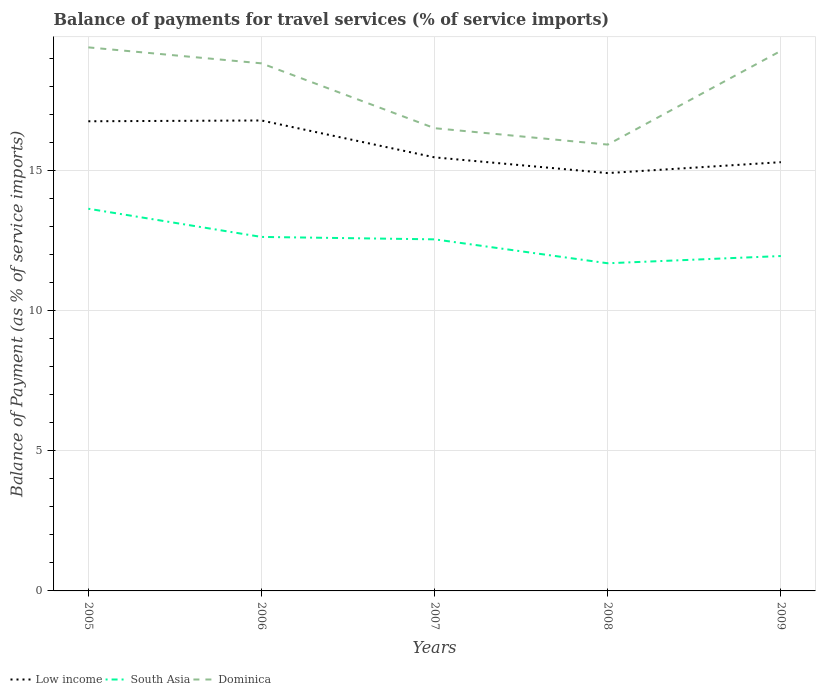Across all years, what is the maximum balance of payments for travel services in South Asia?
Provide a short and direct response. 11.69. What is the total balance of payments for travel services in Low income in the graph?
Your response must be concise. 1.29. What is the difference between the highest and the second highest balance of payments for travel services in Dominica?
Keep it short and to the point. 3.47. What is the difference between the highest and the lowest balance of payments for travel services in South Asia?
Make the answer very short. 3. Is the balance of payments for travel services in South Asia strictly greater than the balance of payments for travel services in Dominica over the years?
Your answer should be very brief. Yes. How many years are there in the graph?
Give a very brief answer. 5. Does the graph contain grids?
Provide a succinct answer. Yes. How are the legend labels stacked?
Offer a terse response. Horizontal. What is the title of the graph?
Make the answer very short. Balance of payments for travel services (% of service imports). Does "Turks and Caicos Islands" appear as one of the legend labels in the graph?
Provide a succinct answer. No. What is the label or title of the Y-axis?
Provide a short and direct response. Balance of Payment (as % of service imports). What is the Balance of Payment (as % of service imports) in Low income in 2005?
Offer a terse response. 16.76. What is the Balance of Payment (as % of service imports) of South Asia in 2005?
Provide a short and direct response. 13.64. What is the Balance of Payment (as % of service imports) in Dominica in 2005?
Provide a short and direct response. 19.4. What is the Balance of Payment (as % of service imports) in Low income in 2006?
Provide a succinct answer. 16.79. What is the Balance of Payment (as % of service imports) of South Asia in 2006?
Your answer should be very brief. 12.63. What is the Balance of Payment (as % of service imports) of Dominica in 2006?
Your response must be concise. 18.83. What is the Balance of Payment (as % of service imports) of Low income in 2007?
Your answer should be compact. 15.47. What is the Balance of Payment (as % of service imports) of South Asia in 2007?
Ensure brevity in your answer.  12.55. What is the Balance of Payment (as % of service imports) in Dominica in 2007?
Your answer should be compact. 16.51. What is the Balance of Payment (as % of service imports) in Low income in 2008?
Keep it short and to the point. 14.91. What is the Balance of Payment (as % of service imports) in South Asia in 2008?
Keep it short and to the point. 11.69. What is the Balance of Payment (as % of service imports) of Dominica in 2008?
Offer a terse response. 15.93. What is the Balance of Payment (as % of service imports) of Low income in 2009?
Offer a terse response. 15.3. What is the Balance of Payment (as % of service imports) of South Asia in 2009?
Make the answer very short. 11.95. What is the Balance of Payment (as % of service imports) of Dominica in 2009?
Ensure brevity in your answer.  19.27. Across all years, what is the maximum Balance of Payment (as % of service imports) in Low income?
Keep it short and to the point. 16.79. Across all years, what is the maximum Balance of Payment (as % of service imports) in South Asia?
Give a very brief answer. 13.64. Across all years, what is the maximum Balance of Payment (as % of service imports) in Dominica?
Make the answer very short. 19.4. Across all years, what is the minimum Balance of Payment (as % of service imports) of Low income?
Give a very brief answer. 14.91. Across all years, what is the minimum Balance of Payment (as % of service imports) of South Asia?
Provide a succinct answer. 11.69. Across all years, what is the minimum Balance of Payment (as % of service imports) of Dominica?
Offer a terse response. 15.93. What is the total Balance of Payment (as % of service imports) in Low income in the graph?
Your answer should be very brief. 79.24. What is the total Balance of Payment (as % of service imports) in South Asia in the graph?
Your response must be concise. 62.46. What is the total Balance of Payment (as % of service imports) of Dominica in the graph?
Your answer should be compact. 89.94. What is the difference between the Balance of Payment (as % of service imports) of Low income in 2005 and that in 2006?
Provide a short and direct response. -0.03. What is the difference between the Balance of Payment (as % of service imports) in South Asia in 2005 and that in 2006?
Make the answer very short. 1.01. What is the difference between the Balance of Payment (as % of service imports) of Dominica in 2005 and that in 2006?
Give a very brief answer. 0.57. What is the difference between the Balance of Payment (as % of service imports) of Low income in 2005 and that in 2007?
Ensure brevity in your answer.  1.29. What is the difference between the Balance of Payment (as % of service imports) of South Asia in 2005 and that in 2007?
Make the answer very short. 1.09. What is the difference between the Balance of Payment (as % of service imports) of Dominica in 2005 and that in 2007?
Offer a terse response. 2.88. What is the difference between the Balance of Payment (as % of service imports) of Low income in 2005 and that in 2008?
Give a very brief answer. 1.85. What is the difference between the Balance of Payment (as % of service imports) in South Asia in 2005 and that in 2008?
Your answer should be compact. 1.95. What is the difference between the Balance of Payment (as % of service imports) of Dominica in 2005 and that in 2008?
Your answer should be very brief. 3.47. What is the difference between the Balance of Payment (as % of service imports) in Low income in 2005 and that in 2009?
Keep it short and to the point. 1.46. What is the difference between the Balance of Payment (as % of service imports) of South Asia in 2005 and that in 2009?
Ensure brevity in your answer.  1.69. What is the difference between the Balance of Payment (as % of service imports) of Dominica in 2005 and that in 2009?
Provide a short and direct response. 0.12. What is the difference between the Balance of Payment (as % of service imports) in Low income in 2006 and that in 2007?
Your answer should be compact. 1.32. What is the difference between the Balance of Payment (as % of service imports) of South Asia in 2006 and that in 2007?
Offer a very short reply. 0.09. What is the difference between the Balance of Payment (as % of service imports) of Dominica in 2006 and that in 2007?
Your response must be concise. 2.31. What is the difference between the Balance of Payment (as % of service imports) of Low income in 2006 and that in 2008?
Your answer should be very brief. 1.88. What is the difference between the Balance of Payment (as % of service imports) of South Asia in 2006 and that in 2008?
Provide a short and direct response. 0.94. What is the difference between the Balance of Payment (as % of service imports) of Dominica in 2006 and that in 2008?
Provide a succinct answer. 2.9. What is the difference between the Balance of Payment (as % of service imports) of Low income in 2006 and that in 2009?
Your answer should be compact. 1.49. What is the difference between the Balance of Payment (as % of service imports) in South Asia in 2006 and that in 2009?
Your answer should be compact. 0.68. What is the difference between the Balance of Payment (as % of service imports) of Dominica in 2006 and that in 2009?
Your response must be concise. -0.45. What is the difference between the Balance of Payment (as % of service imports) of Low income in 2007 and that in 2008?
Your answer should be very brief. 0.56. What is the difference between the Balance of Payment (as % of service imports) of South Asia in 2007 and that in 2008?
Your response must be concise. 0.85. What is the difference between the Balance of Payment (as % of service imports) of Dominica in 2007 and that in 2008?
Your answer should be very brief. 0.59. What is the difference between the Balance of Payment (as % of service imports) of Low income in 2007 and that in 2009?
Offer a terse response. 0.17. What is the difference between the Balance of Payment (as % of service imports) of South Asia in 2007 and that in 2009?
Offer a terse response. 0.6. What is the difference between the Balance of Payment (as % of service imports) in Dominica in 2007 and that in 2009?
Give a very brief answer. -2.76. What is the difference between the Balance of Payment (as % of service imports) of Low income in 2008 and that in 2009?
Ensure brevity in your answer.  -0.39. What is the difference between the Balance of Payment (as % of service imports) in South Asia in 2008 and that in 2009?
Your response must be concise. -0.26. What is the difference between the Balance of Payment (as % of service imports) in Dominica in 2008 and that in 2009?
Your answer should be very brief. -3.35. What is the difference between the Balance of Payment (as % of service imports) of Low income in 2005 and the Balance of Payment (as % of service imports) of South Asia in 2006?
Provide a short and direct response. 4.13. What is the difference between the Balance of Payment (as % of service imports) of Low income in 2005 and the Balance of Payment (as % of service imports) of Dominica in 2006?
Offer a very short reply. -2.07. What is the difference between the Balance of Payment (as % of service imports) of South Asia in 2005 and the Balance of Payment (as % of service imports) of Dominica in 2006?
Provide a short and direct response. -5.19. What is the difference between the Balance of Payment (as % of service imports) of Low income in 2005 and the Balance of Payment (as % of service imports) of South Asia in 2007?
Your answer should be very brief. 4.21. What is the difference between the Balance of Payment (as % of service imports) of Low income in 2005 and the Balance of Payment (as % of service imports) of Dominica in 2007?
Give a very brief answer. 0.25. What is the difference between the Balance of Payment (as % of service imports) of South Asia in 2005 and the Balance of Payment (as % of service imports) of Dominica in 2007?
Your response must be concise. -2.87. What is the difference between the Balance of Payment (as % of service imports) of Low income in 2005 and the Balance of Payment (as % of service imports) of South Asia in 2008?
Offer a very short reply. 5.07. What is the difference between the Balance of Payment (as % of service imports) in Low income in 2005 and the Balance of Payment (as % of service imports) in Dominica in 2008?
Make the answer very short. 0.83. What is the difference between the Balance of Payment (as % of service imports) in South Asia in 2005 and the Balance of Payment (as % of service imports) in Dominica in 2008?
Offer a very short reply. -2.29. What is the difference between the Balance of Payment (as % of service imports) in Low income in 2005 and the Balance of Payment (as % of service imports) in South Asia in 2009?
Your answer should be very brief. 4.81. What is the difference between the Balance of Payment (as % of service imports) of Low income in 2005 and the Balance of Payment (as % of service imports) of Dominica in 2009?
Provide a succinct answer. -2.51. What is the difference between the Balance of Payment (as % of service imports) of South Asia in 2005 and the Balance of Payment (as % of service imports) of Dominica in 2009?
Your response must be concise. -5.63. What is the difference between the Balance of Payment (as % of service imports) of Low income in 2006 and the Balance of Payment (as % of service imports) of South Asia in 2007?
Your answer should be compact. 4.24. What is the difference between the Balance of Payment (as % of service imports) in Low income in 2006 and the Balance of Payment (as % of service imports) in Dominica in 2007?
Provide a succinct answer. 0.28. What is the difference between the Balance of Payment (as % of service imports) in South Asia in 2006 and the Balance of Payment (as % of service imports) in Dominica in 2007?
Your response must be concise. -3.88. What is the difference between the Balance of Payment (as % of service imports) of Low income in 2006 and the Balance of Payment (as % of service imports) of South Asia in 2008?
Provide a short and direct response. 5.1. What is the difference between the Balance of Payment (as % of service imports) of Low income in 2006 and the Balance of Payment (as % of service imports) of Dominica in 2008?
Your response must be concise. 0.86. What is the difference between the Balance of Payment (as % of service imports) in South Asia in 2006 and the Balance of Payment (as % of service imports) in Dominica in 2008?
Provide a short and direct response. -3.3. What is the difference between the Balance of Payment (as % of service imports) of Low income in 2006 and the Balance of Payment (as % of service imports) of South Asia in 2009?
Provide a succinct answer. 4.84. What is the difference between the Balance of Payment (as % of service imports) in Low income in 2006 and the Balance of Payment (as % of service imports) in Dominica in 2009?
Your answer should be very brief. -2.48. What is the difference between the Balance of Payment (as % of service imports) of South Asia in 2006 and the Balance of Payment (as % of service imports) of Dominica in 2009?
Your answer should be very brief. -6.64. What is the difference between the Balance of Payment (as % of service imports) of Low income in 2007 and the Balance of Payment (as % of service imports) of South Asia in 2008?
Your answer should be very brief. 3.78. What is the difference between the Balance of Payment (as % of service imports) of Low income in 2007 and the Balance of Payment (as % of service imports) of Dominica in 2008?
Make the answer very short. -0.46. What is the difference between the Balance of Payment (as % of service imports) in South Asia in 2007 and the Balance of Payment (as % of service imports) in Dominica in 2008?
Your answer should be very brief. -3.38. What is the difference between the Balance of Payment (as % of service imports) in Low income in 2007 and the Balance of Payment (as % of service imports) in South Asia in 2009?
Make the answer very short. 3.52. What is the difference between the Balance of Payment (as % of service imports) of Low income in 2007 and the Balance of Payment (as % of service imports) of Dominica in 2009?
Keep it short and to the point. -3.8. What is the difference between the Balance of Payment (as % of service imports) of South Asia in 2007 and the Balance of Payment (as % of service imports) of Dominica in 2009?
Your response must be concise. -6.73. What is the difference between the Balance of Payment (as % of service imports) of Low income in 2008 and the Balance of Payment (as % of service imports) of South Asia in 2009?
Offer a terse response. 2.96. What is the difference between the Balance of Payment (as % of service imports) of Low income in 2008 and the Balance of Payment (as % of service imports) of Dominica in 2009?
Provide a short and direct response. -4.36. What is the difference between the Balance of Payment (as % of service imports) of South Asia in 2008 and the Balance of Payment (as % of service imports) of Dominica in 2009?
Offer a very short reply. -7.58. What is the average Balance of Payment (as % of service imports) of Low income per year?
Your answer should be compact. 15.85. What is the average Balance of Payment (as % of service imports) of South Asia per year?
Offer a terse response. 12.49. What is the average Balance of Payment (as % of service imports) of Dominica per year?
Your answer should be very brief. 17.99. In the year 2005, what is the difference between the Balance of Payment (as % of service imports) of Low income and Balance of Payment (as % of service imports) of South Asia?
Ensure brevity in your answer.  3.12. In the year 2005, what is the difference between the Balance of Payment (as % of service imports) of Low income and Balance of Payment (as % of service imports) of Dominica?
Ensure brevity in your answer.  -2.64. In the year 2005, what is the difference between the Balance of Payment (as % of service imports) in South Asia and Balance of Payment (as % of service imports) in Dominica?
Make the answer very short. -5.76. In the year 2006, what is the difference between the Balance of Payment (as % of service imports) of Low income and Balance of Payment (as % of service imports) of South Asia?
Your answer should be compact. 4.16. In the year 2006, what is the difference between the Balance of Payment (as % of service imports) of Low income and Balance of Payment (as % of service imports) of Dominica?
Keep it short and to the point. -2.04. In the year 2006, what is the difference between the Balance of Payment (as % of service imports) of South Asia and Balance of Payment (as % of service imports) of Dominica?
Give a very brief answer. -6.2. In the year 2007, what is the difference between the Balance of Payment (as % of service imports) in Low income and Balance of Payment (as % of service imports) in South Asia?
Provide a succinct answer. 2.93. In the year 2007, what is the difference between the Balance of Payment (as % of service imports) in Low income and Balance of Payment (as % of service imports) in Dominica?
Make the answer very short. -1.04. In the year 2007, what is the difference between the Balance of Payment (as % of service imports) of South Asia and Balance of Payment (as % of service imports) of Dominica?
Your answer should be very brief. -3.97. In the year 2008, what is the difference between the Balance of Payment (as % of service imports) in Low income and Balance of Payment (as % of service imports) in South Asia?
Offer a terse response. 3.22. In the year 2008, what is the difference between the Balance of Payment (as % of service imports) of Low income and Balance of Payment (as % of service imports) of Dominica?
Your answer should be compact. -1.02. In the year 2008, what is the difference between the Balance of Payment (as % of service imports) of South Asia and Balance of Payment (as % of service imports) of Dominica?
Give a very brief answer. -4.24. In the year 2009, what is the difference between the Balance of Payment (as % of service imports) of Low income and Balance of Payment (as % of service imports) of South Asia?
Give a very brief answer. 3.35. In the year 2009, what is the difference between the Balance of Payment (as % of service imports) of Low income and Balance of Payment (as % of service imports) of Dominica?
Ensure brevity in your answer.  -3.97. In the year 2009, what is the difference between the Balance of Payment (as % of service imports) in South Asia and Balance of Payment (as % of service imports) in Dominica?
Offer a very short reply. -7.32. What is the ratio of the Balance of Payment (as % of service imports) of Low income in 2005 to that in 2006?
Make the answer very short. 1. What is the ratio of the Balance of Payment (as % of service imports) in South Asia in 2005 to that in 2006?
Keep it short and to the point. 1.08. What is the ratio of the Balance of Payment (as % of service imports) of Dominica in 2005 to that in 2006?
Keep it short and to the point. 1.03. What is the ratio of the Balance of Payment (as % of service imports) in Low income in 2005 to that in 2007?
Provide a succinct answer. 1.08. What is the ratio of the Balance of Payment (as % of service imports) in South Asia in 2005 to that in 2007?
Keep it short and to the point. 1.09. What is the ratio of the Balance of Payment (as % of service imports) in Dominica in 2005 to that in 2007?
Make the answer very short. 1.17. What is the ratio of the Balance of Payment (as % of service imports) of Low income in 2005 to that in 2008?
Keep it short and to the point. 1.12. What is the ratio of the Balance of Payment (as % of service imports) in South Asia in 2005 to that in 2008?
Provide a short and direct response. 1.17. What is the ratio of the Balance of Payment (as % of service imports) in Dominica in 2005 to that in 2008?
Keep it short and to the point. 1.22. What is the ratio of the Balance of Payment (as % of service imports) of Low income in 2005 to that in 2009?
Your answer should be very brief. 1.1. What is the ratio of the Balance of Payment (as % of service imports) of South Asia in 2005 to that in 2009?
Ensure brevity in your answer.  1.14. What is the ratio of the Balance of Payment (as % of service imports) in Low income in 2006 to that in 2007?
Offer a terse response. 1.09. What is the ratio of the Balance of Payment (as % of service imports) of Dominica in 2006 to that in 2007?
Offer a terse response. 1.14. What is the ratio of the Balance of Payment (as % of service imports) in Low income in 2006 to that in 2008?
Your response must be concise. 1.13. What is the ratio of the Balance of Payment (as % of service imports) of South Asia in 2006 to that in 2008?
Offer a very short reply. 1.08. What is the ratio of the Balance of Payment (as % of service imports) in Dominica in 2006 to that in 2008?
Provide a succinct answer. 1.18. What is the ratio of the Balance of Payment (as % of service imports) in Low income in 2006 to that in 2009?
Your answer should be compact. 1.1. What is the ratio of the Balance of Payment (as % of service imports) of South Asia in 2006 to that in 2009?
Your response must be concise. 1.06. What is the ratio of the Balance of Payment (as % of service imports) of Dominica in 2006 to that in 2009?
Keep it short and to the point. 0.98. What is the ratio of the Balance of Payment (as % of service imports) of Low income in 2007 to that in 2008?
Keep it short and to the point. 1.04. What is the ratio of the Balance of Payment (as % of service imports) in South Asia in 2007 to that in 2008?
Offer a terse response. 1.07. What is the ratio of the Balance of Payment (as % of service imports) in Dominica in 2007 to that in 2008?
Give a very brief answer. 1.04. What is the ratio of the Balance of Payment (as % of service imports) in Low income in 2007 to that in 2009?
Provide a succinct answer. 1.01. What is the ratio of the Balance of Payment (as % of service imports) in South Asia in 2007 to that in 2009?
Ensure brevity in your answer.  1.05. What is the ratio of the Balance of Payment (as % of service imports) in Dominica in 2007 to that in 2009?
Offer a terse response. 0.86. What is the ratio of the Balance of Payment (as % of service imports) of Low income in 2008 to that in 2009?
Ensure brevity in your answer.  0.97. What is the ratio of the Balance of Payment (as % of service imports) of South Asia in 2008 to that in 2009?
Offer a very short reply. 0.98. What is the ratio of the Balance of Payment (as % of service imports) in Dominica in 2008 to that in 2009?
Keep it short and to the point. 0.83. What is the difference between the highest and the second highest Balance of Payment (as % of service imports) in Low income?
Make the answer very short. 0.03. What is the difference between the highest and the second highest Balance of Payment (as % of service imports) in South Asia?
Offer a terse response. 1.01. What is the difference between the highest and the second highest Balance of Payment (as % of service imports) in Dominica?
Your answer should be very brief. 0.12. What is the difference between the highest and the lowest Balance of Payment (as % of service imports) in Low income?
Your response must be concise. 1.88. What is the difference between the highest and the lowest Balance of Payment (as % of service imports) of South Asia?
Your answer should be compact. 1.95. What is the difference between the highest and the lowest Balance of Payment (as % of service imports) in Dominica?
Offer a very short reply. 3.47. 